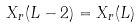Convert formula to latex. <formula><loc_0><loc_0><loc_500><loc_500>X _ { r } ( L - 2 ) = X _ { r } ( L )</formula> 